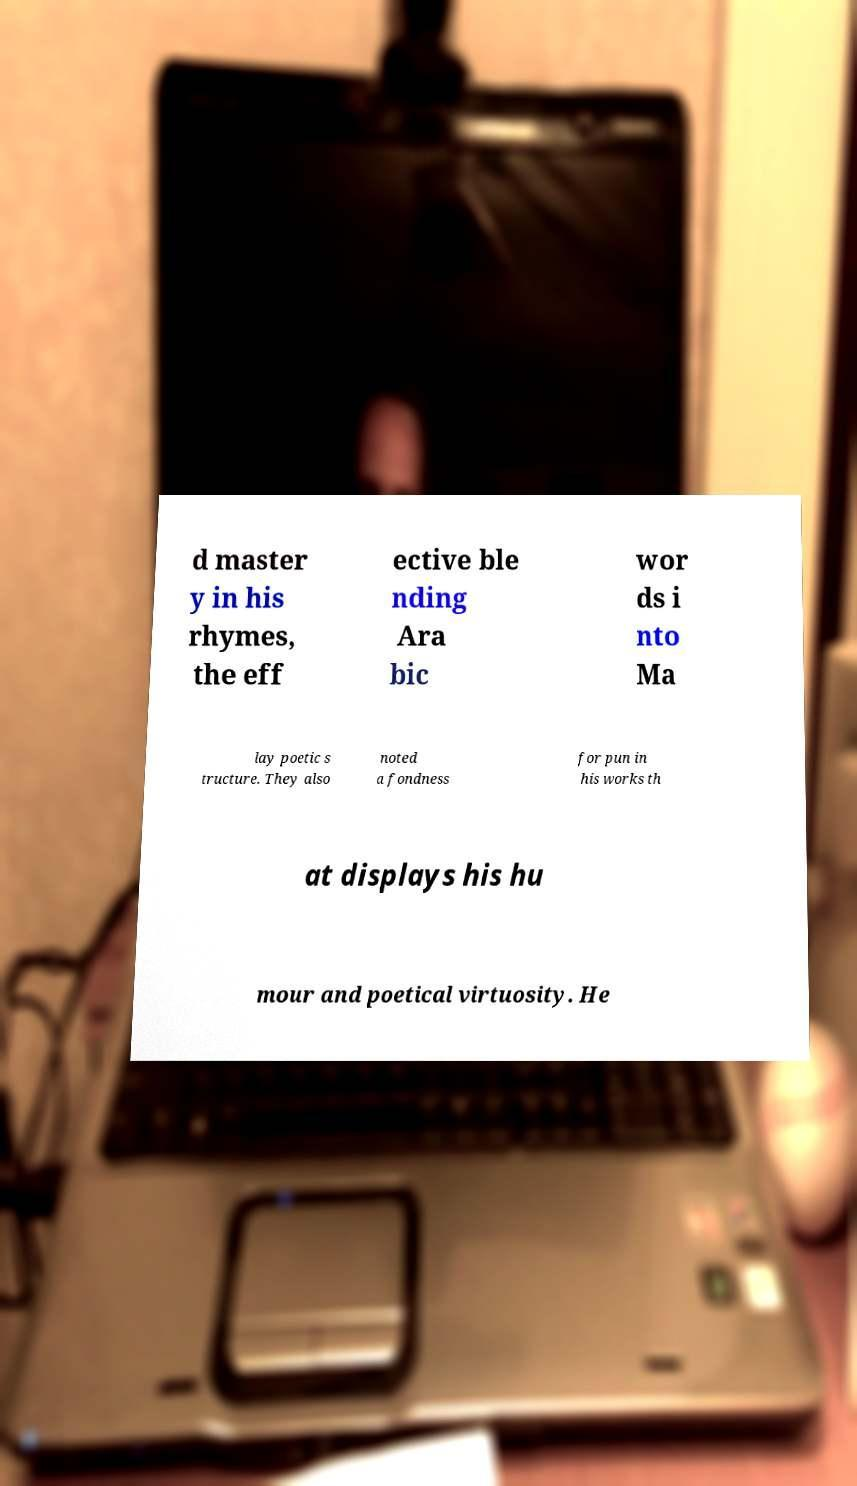Can you read and provide the text displayed in the image?This photo seems to have some interesting text. Can you extract and type it out for me? d master y in his rhymes, the eff ective ble nding Ara bic wor ds i nto Ma lay poetic s tructure. They also noted a fondness for pun in his works th at displays his hu mour and poetical virtuosity. He 